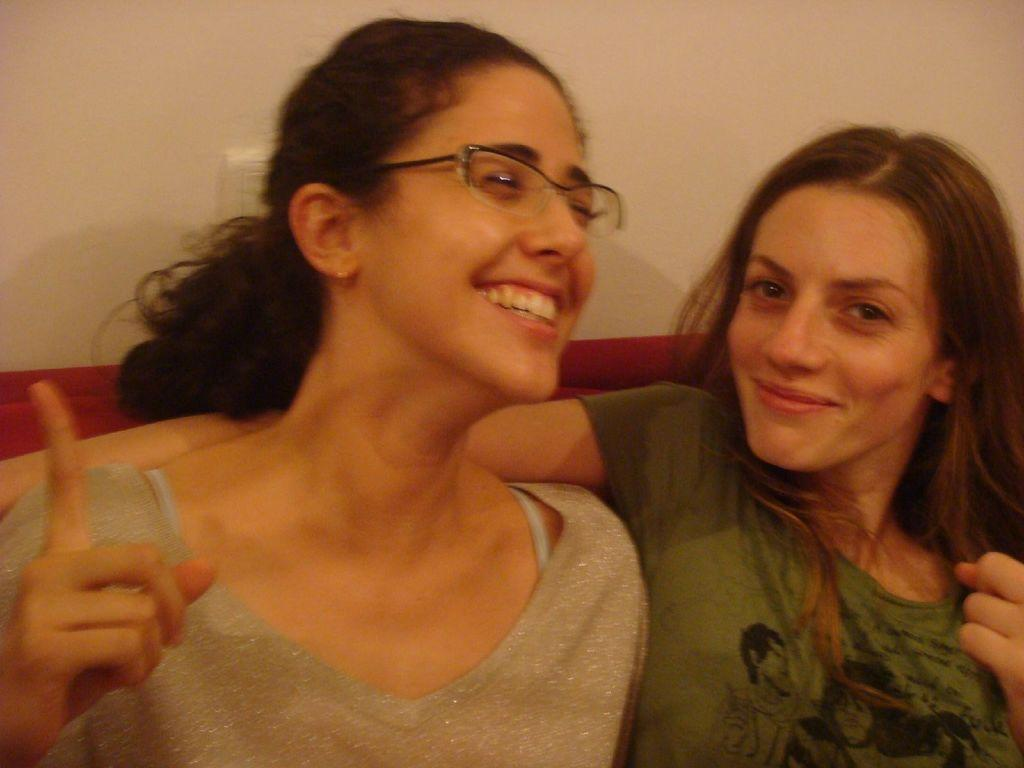How many people are sitting in the center of the image? There are two ladies sitting in the center of the image. Can you describe the appearance of the lady sitting on the left? The lady sitting on the left is wearing glasses. What can be seen in the background of the image? There is a wall in the background of the image. Where are the dolls placed in the image? There are no dolls present in the image. What type of coach can be seen in the image? There is no coach present in the image. 